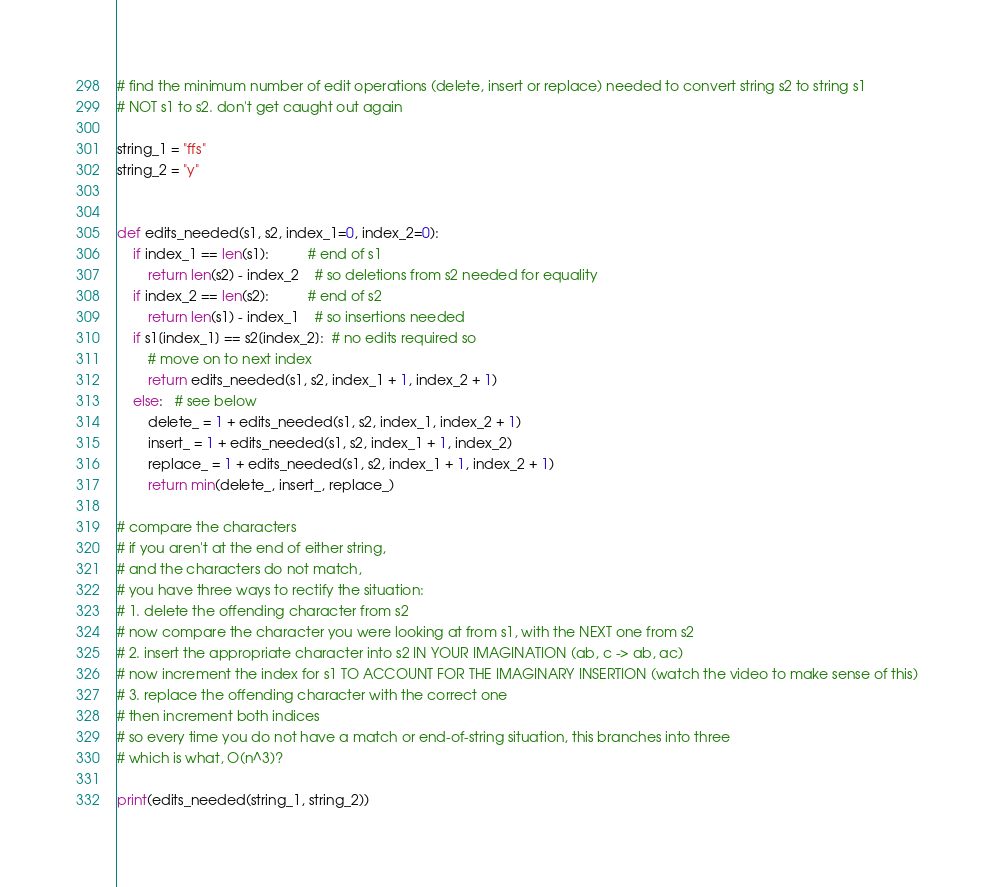<code> <loc_0><loc_0><loc_500><loc_500><_Python_># find the minimum number of edit operations (delete, insert or replace) needed to convert string s2 to string s1
# NOT s1 to s2. don't get caught out again

string_1 = "ffs"
string_2 = "y"


def edits_needed(s1, s2, index_1=0, index_2=0):
    if index_1 == len(s1):          # end of s1
        return len(s2) - index_2    # so deletions from s2 needed for equality
    if index_2 == len(s2):          # end of s2
        return len(s1) - index_1    # so insertions needed
    if s1[index_1] == s2[index_2]:  # no edits required so
        # move on to next index
        return edits_needed(s1, s2, index_1 + 1, index_2 + 1)
    else:   # see below
        delete_ = 1 + edits_needed(s1, s2, index_1, index_2 + 1)
        insert_ = 1 + edits_needed(s1, s2, index_1 + 1, index_2)
        replace_ = 1 + edits_needed(s1, s2, index_1 + 1, index_2 + 1)
        return min(delete_, insert_, replace_)

# compare the characters
# if you aren't at the end of either string,
# and the characters do not match,
# you have three ways to rectify the situation:
# 1. delete the offending character from s2
# now compare the character you were looking at from s1, with the NEXT one from s2
# 2. insert the appropriate character into s2 IN YOUR IMAGINATION (ab, c -> ab, ac)
# now increment the index for s1 TO ACCOUNT FOR THE IMAGINARY INSERTION (watch the video to make sense of this)
# 3. replace the offending character with the correct one
# then increment both indices
# so every time you do not have a match or end-of-string situation, this branches into three
# which is what, O(n^3)?

print(edits_needed(string_1, string_2))
</code> 